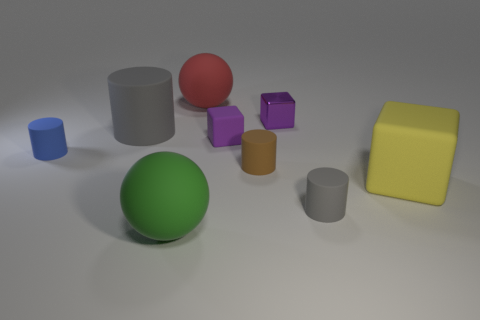Add 1 large brown blocks. How many objects exist? 10 Subtract all spheres. How many objects are left? 7 Add 8 big green matte objects. How many big green matte objects are left? 9 Add 3 gray rubber blocks. How many gray rubber blocks exist? 3 Subtract 0 brown balls. How many objects are left? 9 Subtract all balls. Subtract all big red matte balls. How many objects are left? 6 